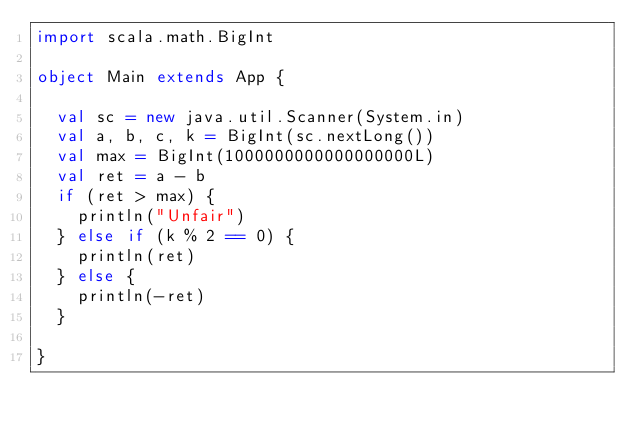<code> <loc_0><loc_0><loc_500><loc_500><_Scala_>import scala.math.BigInt

object Main extends App {
  
  val sc = new java.util.Scanner(System.in)
  val a, b, c, k = BigInt(sc.nextLong())
  val max = BigInt(1000000000000000000L)
  val ret = a - b
  if (ret > max) {
    println("Unfair")
  } else if (k % 2 == 0) {
    println(ret)    
  } else {
    println(-ret)
  }

}</code> 